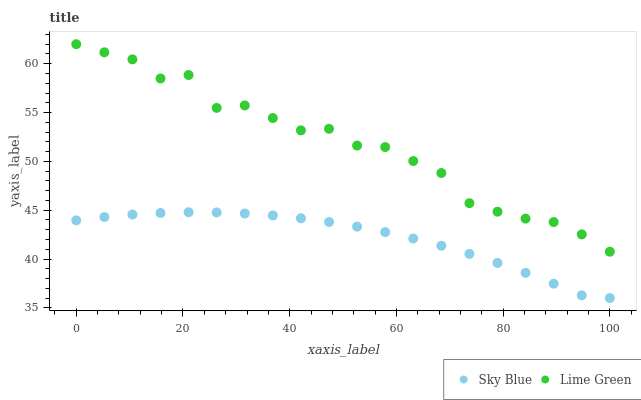Does Sky Blue have the minimum area under the curve?
Answer yes or no. Yes. Does Lime Green have the maximum area under the curve?
Answer yes or no. Yes. Does Lime Green have the minimum area under the curve?
Answer yes or no. No. Is Sky Blue the smoothest?
Answer yes or no. Yes. Is Lime Green the roughest?
Answer yes or no. Yes. Is Lime Green the smoothest?
Answer yes or no. No. Does Sky Blue have the lowest value?
Answer yes or no. Yes. Does Lime Green have the lowest value?
Answer yes or no. No. Does Lime Green have the highest value?
Answer yes or no. Yes. Is Sky Blue less than Lime Green?
Answer yes or no. Yes. Is Lime Green greater than Sky Blue?
Answer yes or no. Yes. Does Sky Blue intersect Lime Green?
Answer yes or no. No. 